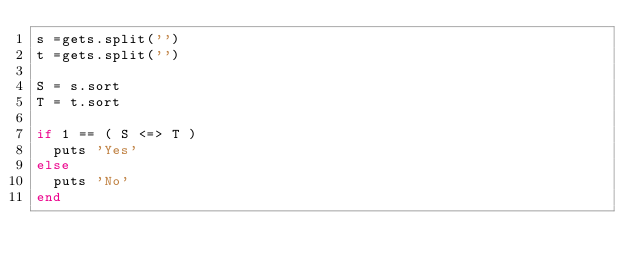Convert code to text. <code><loc_0><loc_0><loc_500><loc_500><_Ruby_>s =gets.split('')
t =gets.split('')

S = s.sort
T = t.sort

if 1 == ( S <=> T )
  puts 'Yes'
else
  puts 'No'
end</code> 